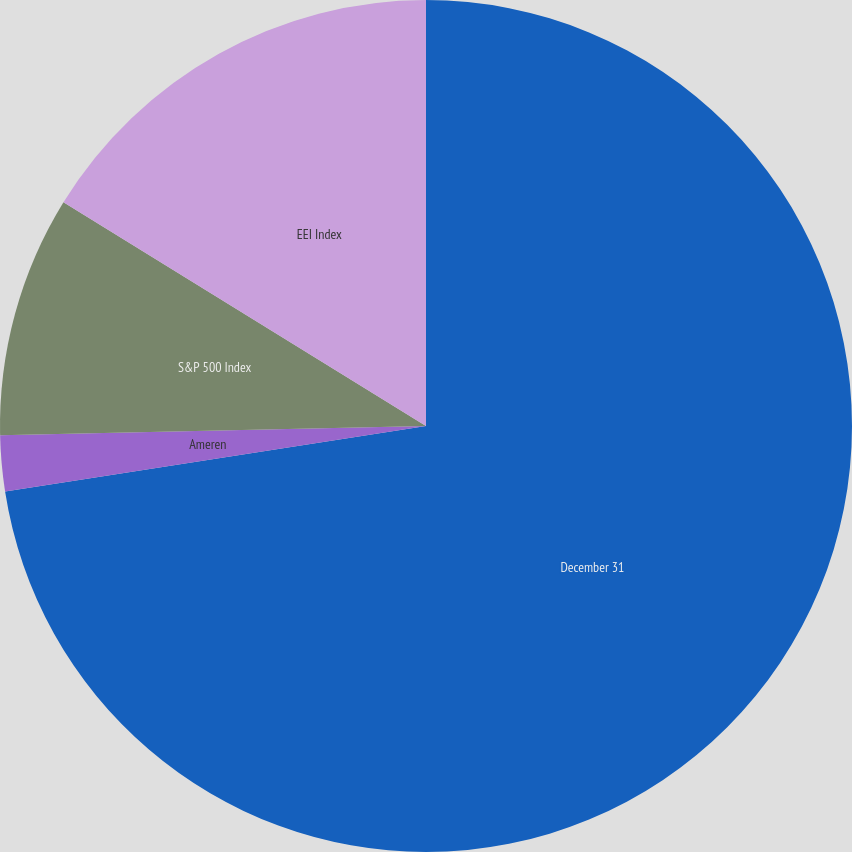<chart> <loc_0><loc_0><loc_500><loc_500><pie_chart><fcel>December 31<fcel>Ameren<fcel>S&P 500 Index<fcel>EEI Index<nl><fcel>72.54%<fcel>2.11%<fcel>9.15%<fcel>16.2%<nl></chart> 